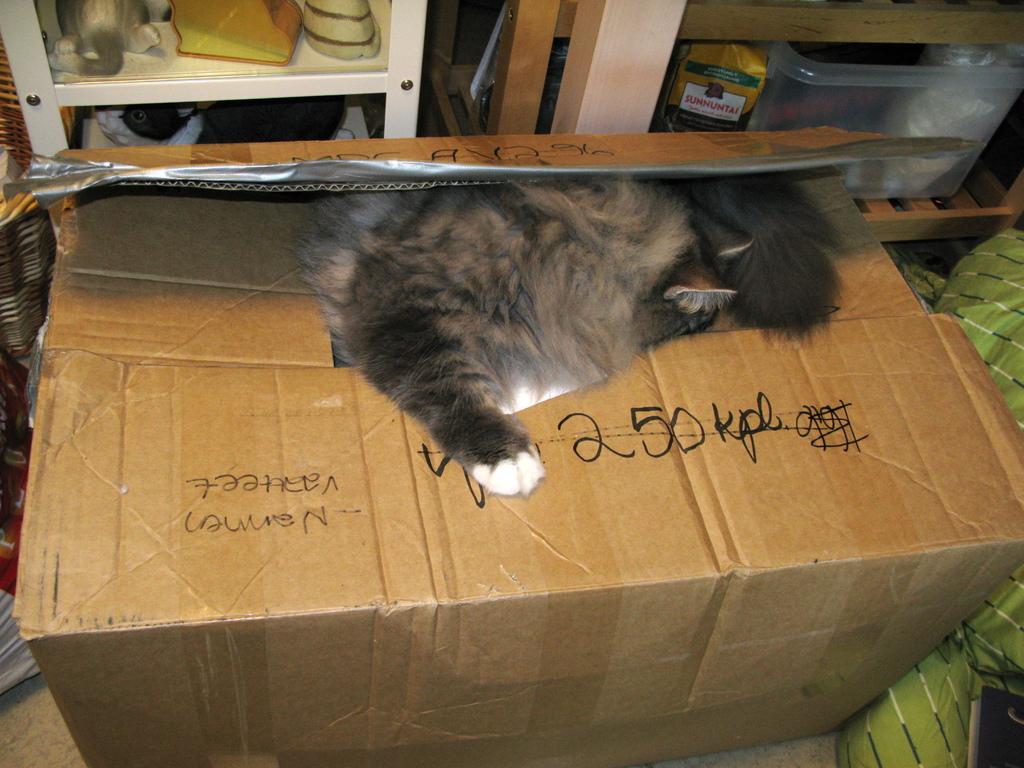What is written along the box?
Your answer should be compact. 250 kpl. What is on the gold bag on the shelf?
Give a very brief answer. Sunnuntai. 